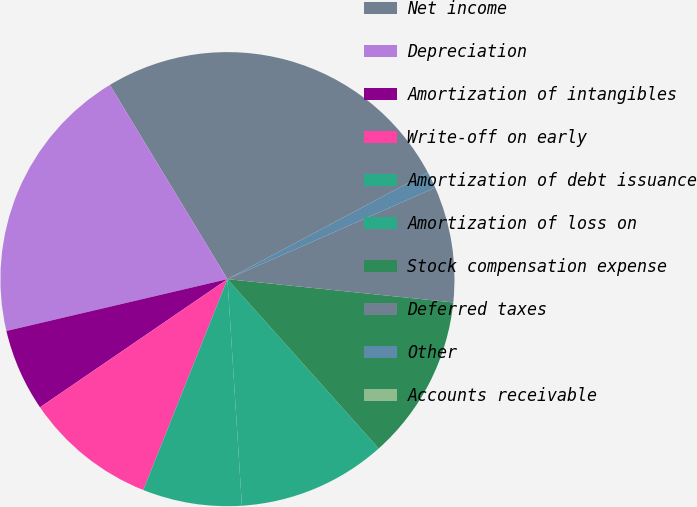<chart> <loc_0><loc_0><loc_500><loc_500><pie_chart><fcel>Net income<fcel>Depreciation<fcel>Amortization of intangibles<fcel>Write-off on early<fcel>Amortization of debt issuance<fcel>Amortization of loss on<fcel>Stock compensation expense<fcel>Deferred taxes<fcel>Other<fcel>Accounts receivable<nl><fcel>25.88%<fcel>20.0%<fcel>5.88%<fcel>9.41%<fcel>7.06%<fcel>10.59%<fcel>11.76%<fcel>8.24%<fcel>1.18%<fcel>0.0%<nl></chart> 